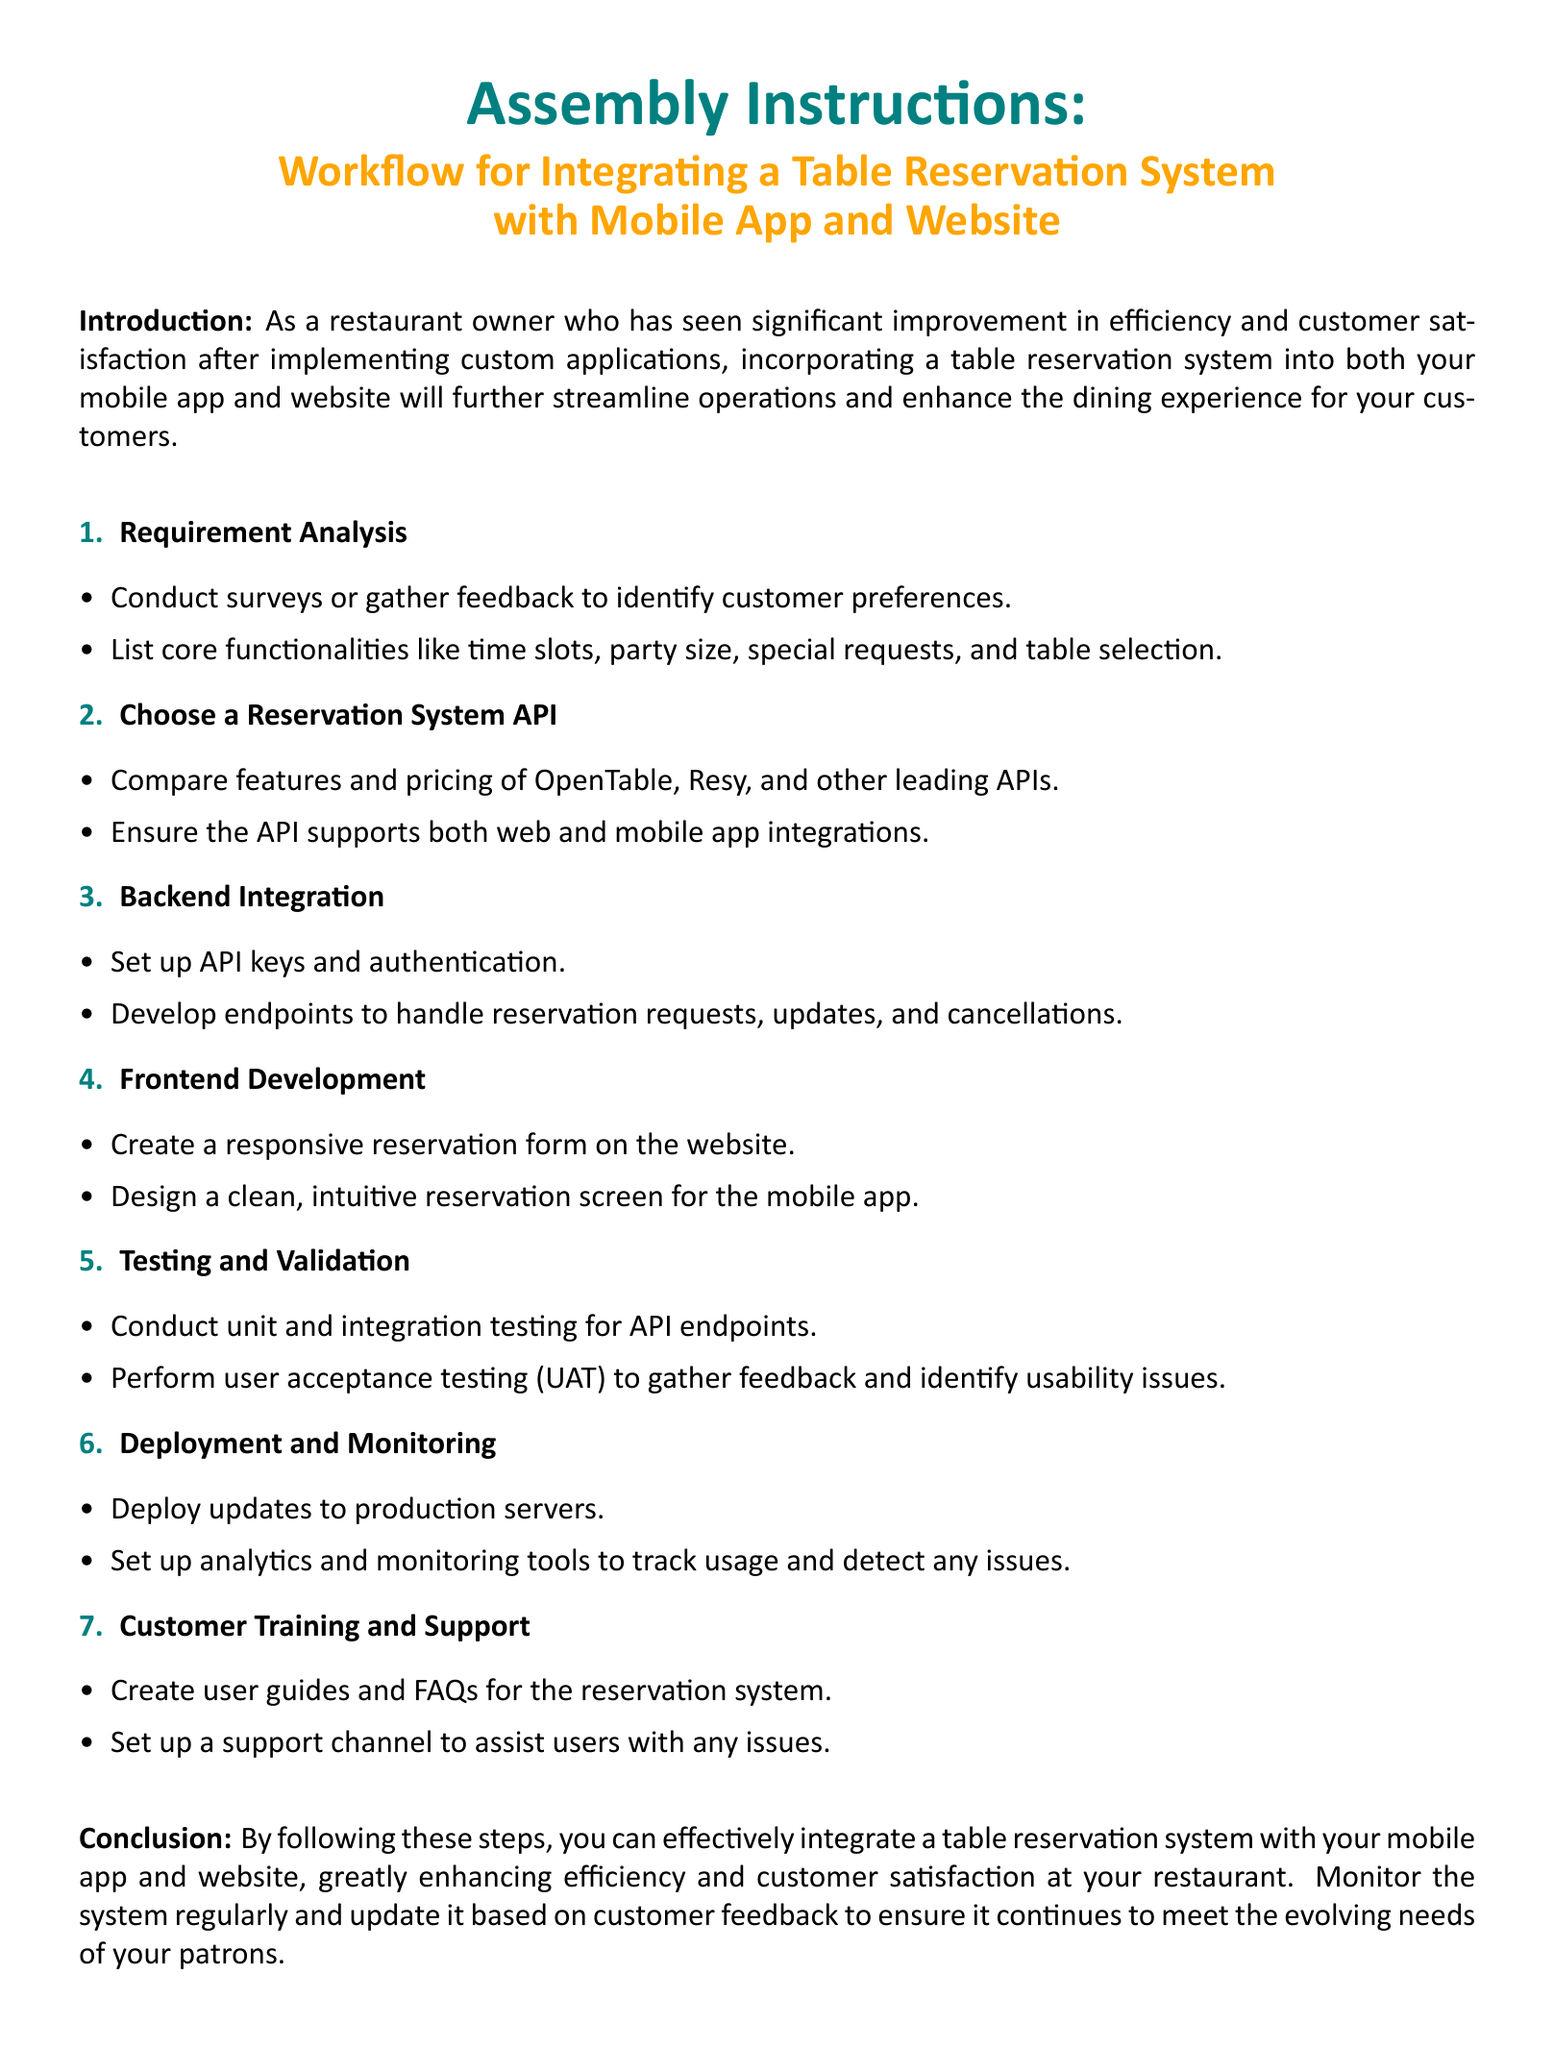What is the document about? The document discusses the workflow for integrating a table reservation system with mobile apps and websites.
Answer: Integration of a Table Reservation System What is the first step in the workflow? The first step in the workflow is to conduct requirement analysis.
Answer: Requirement Analysis Which APIs are suggested for comparison? The document suggests comparing OpenTable and Resy among other leading APIs.
Answer: OpenTable, Resy How many main steps are listed in the workflow? There are seven main steps outlined in the workflow.
Answer: Seven What is the purpose of the 'Testing and Validation' section? This section is to conduct unit and integration testing as well as user acceptance testing.
Answer: Testing and Validation What is recommended for customer support? The document recommends setting up a support channel to assist users with any issues.
Answer: Support Channel What type of tools should be set up for monitoring? The document mentions setting up analytics and monitoring tools.
Answer: Analytics and Monitoring Tools What is one of the functionalities to identify during requirement analysis? Special requests are one of the functionalities to identify.
Answer: Special Requests 